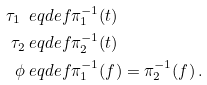<formula> <loc_0><loc_0><loc_500><loc_500>\tau _ { 1 } \ e q d e f & \pi _ { 1 } ^ { - 1 } ( t ) \\ \tau _ { 2 } \ e q d e f & \pi _ { 2 } ^ { - 1 } ( t ) \\ \phi \ e q d e f & \pi _ { 1 } ^ { - 1 } ( f ) = \pi _ { 2 } ^ { - 1 } ( f ) \, .</formula> 